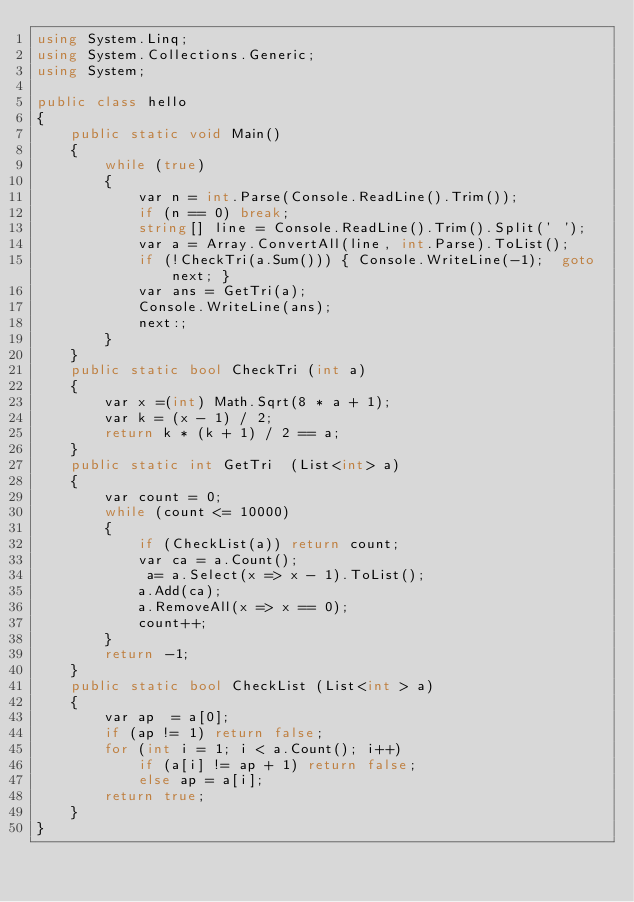Convert code to text. <code><loc_0><loc_0><loc_500><loc_500><_C#_>using System.Linq;
using System.Collections.Generic;
using System;

public class hello
{
    public static void Main()
    {
        while (true)
        {
            var n = int.Parse(Console.ReadLine().Trim());
            if (n == 0) break;
            string[] line = Console.ReadLine().Trim().Split(' ');
            var a = Array.ConvertAll(line, int.Parse).ToList();
            if (!CheckTri(a.Sum())) { Console.WriteLine(-1);  goto next; }
            var ans = GetTri(a);
            Console.WriteLine(ans);
            next:;
        }
    }
    public static bool CheckTri (int a)
    {
        var x =(int) Math.Sqrt(8 * a + 1);
        var k = (x - 1) / 2;
        return k * (k + 1) / 2 == a;
    }
    public static int GetTri  (List<int> a)
    {
        var count = 0;
        while (count <= 10000)
        {
            if (CheckList(a)) return count;
            var ca = a.Count();
             a= a.Select(x => x - 1).ToList();
            a.Add(ca);
            a.RemoveAll(x => x == 0);
            count++;
        }
        return -1;
    }
    public static bool CheckList (List<int > a)
    {
        var ap  = a[0];
        if (ap != 1) return false;
        for (int i = 1; i < a.Count(); i++)
            if (a[i] != ap + 1) return false;
            else ap = a[i];
        return true;
    }
}</code> 